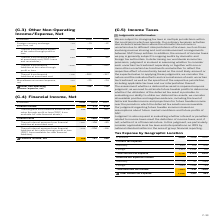According to Sap Ag's financial document, What does the table represent? Tax Expense by Geographic Location. The document states: "Tax Expense by Geographic Location..." Also, In which years was the Tax Expense by Geographic Location calculated? The document contains multiple relevant values: 2019, 2018, 2017. From the document: "€ millions 2019 2018 2017 € millions 2019 2018 2017 € millions 2019 2018 2017..." Also, What are the geographic locations in the table considered when calculating the total current tax expense? The document shows two values: Germany and Foreign. From the document: "Germany 625 733 935 Foreign 1,153 1,019 716..." Additionally, In which year was the current tax expense in Germany the largest? According to the financial document, 2017. The relevant text states: "€ millions 2019 2018 2017..." Also, can you calculate: What was the change in current tax expense in Germany in 2019 from 2018? Based on the calculation: 625-733, the result is -108 (in millions). This is based on the information: "Germany 625 733 935 Germany 625 733 935..." The key data points involved are: 625, 733. Also, can you calculate: What was the percentage change in current tax expense in Germany in 2019 from 2018? To answer this question, I need to perform calculations using the financial data. The calculation is: (625-733)/733, which equals -14.73 (percentage). This is based on the information: "Germany 625 733 935 Germany 625 733 935..." The key data points involved are: 625, 733. 